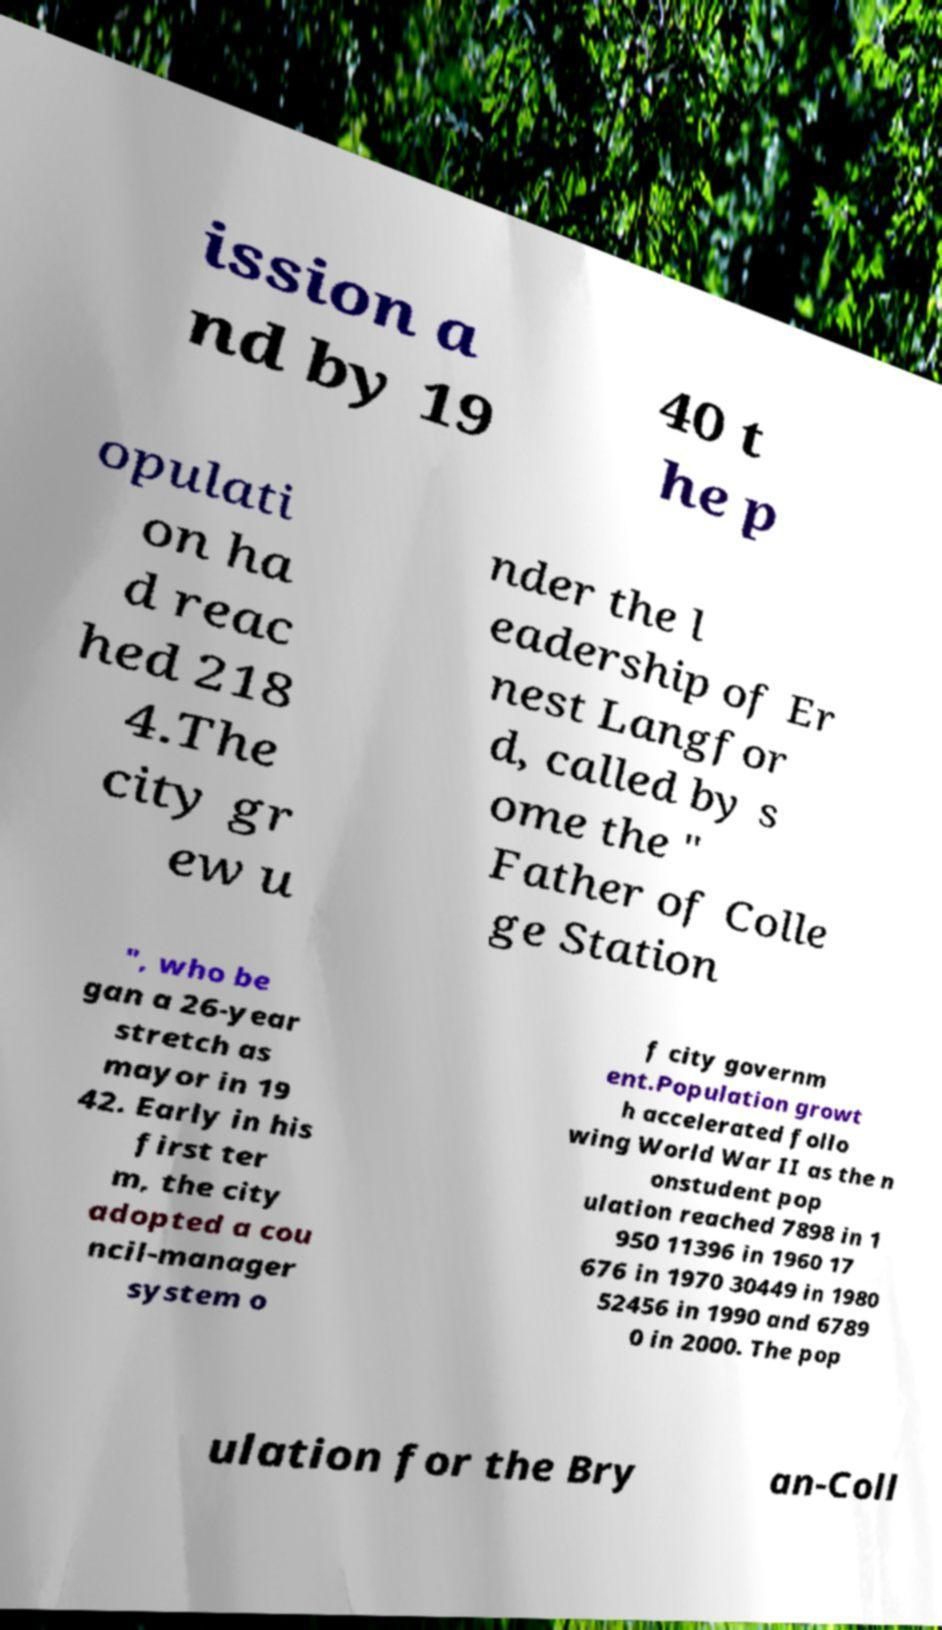Please identify and transcribe the text found in this image. ission a nd by 19 40 t he p opulati on ha d reac hed 218 4.The city gr ew u nder the l eadership of Er nest Langfor d, called by s ome the " Father of Colle ge Station ", who be gan a 26-year stretch as mayor in 19 42. Early in his first ter m, the city adopted a cou ncil-manager system o f city governm ent.Population growt h accelerated follo wing World War II as the n onstudent pop ulation reached 7898 in 1 950 11396 in 1960 17 676 in 1970 30449 in 1980 52456 in 1990 and 6789 0 in 2000. The pop ulation for the Bry an-Coll 